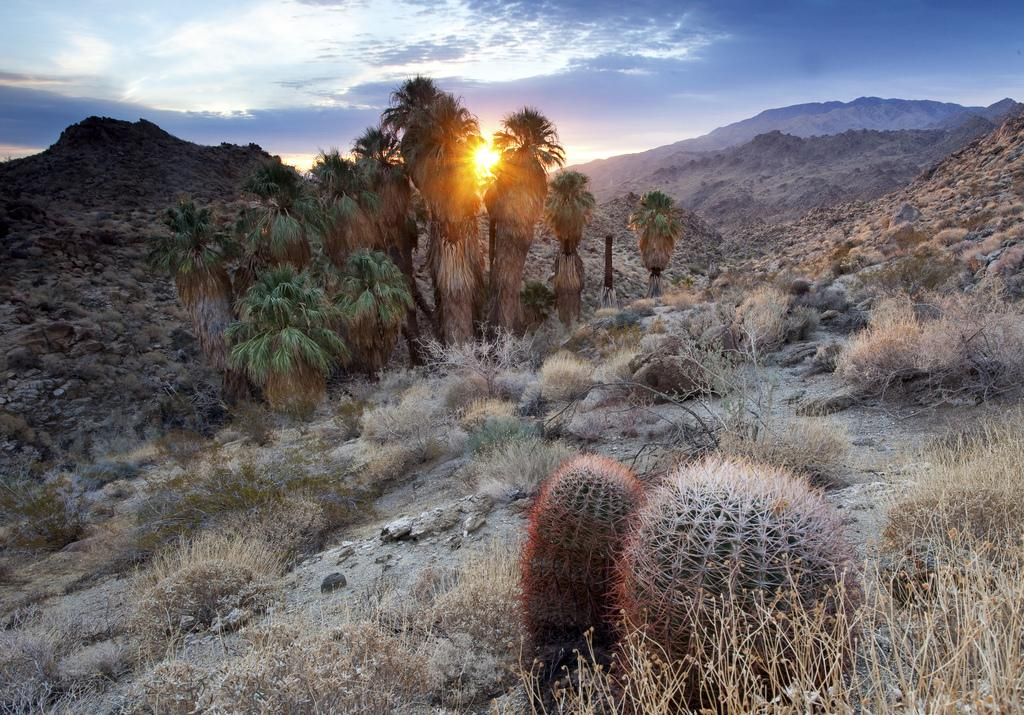What type of plants can be seen in the image? There are cactus plants in the image. What is the condition of the plants on the ground in the image? The plants on the ground in the image are dry. What other type of vegetation is present in the image? There are trees in the image. What can be seen in the distance in the image? There are hills visible in the background of the image. What is visible at the top of the image? The sky is clear and visible at the top of the image. What type of badge is being worn by the cactus in the image? There are no badges present in the image, as it features plants and natural scenery. What type of furniture can be seen in the image? There is no furniture present in the image; it features plants and natural scenery. 